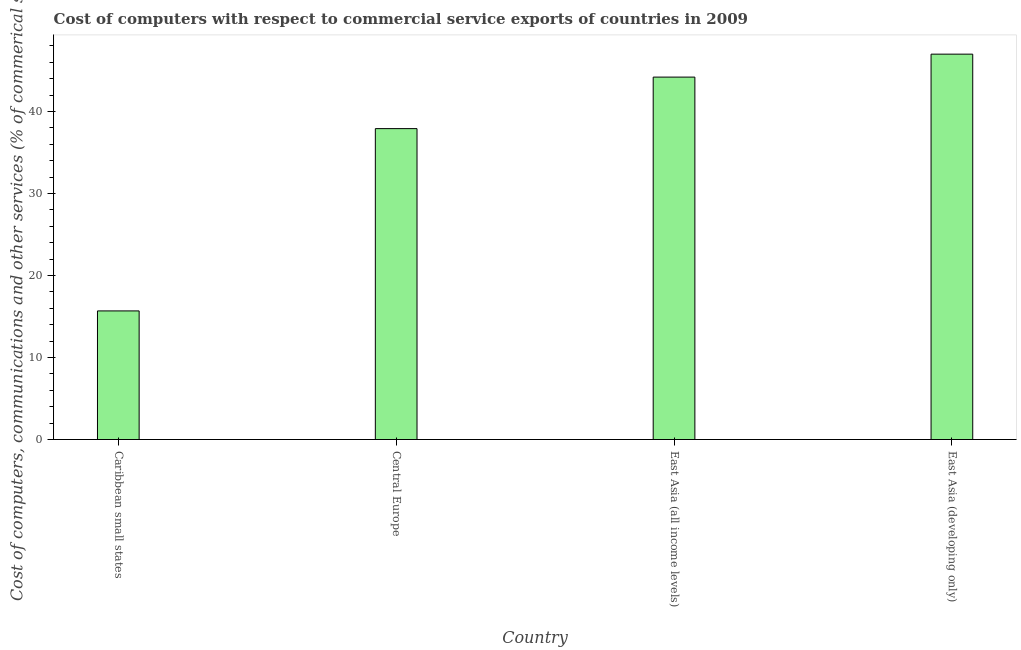Does the graph contain any zero values?
Make the answer very short. No. What is the title of the graph?
Your response must be concise. Cost of computers with respect to commercial service exports of countries in 2009. What is the label or title of the Y-axis?
Give a very brief answer. Cost of computers, communications and other services (% of commerical service exports). What is the cost of communications in Central Europe?
Make the answer very short. 37.91. Across all countries, what is the maximum  computer and other services?
Provide a succinct answer. 47. Across all countries, what is the minimum  computer and other services?
Your response must be concise. 15.68. In which country was the  computer and other services maximum?
Offer a terse response. East Asia (developing only). In which country was the  computer and other services minimum?
Offer a very short reply. Caribbean small states. What is the sum of the cost of communications?
Keep it short and to the point. 144.79. What is the difference between the  computer and other services in Central Europe and East Asia (all income levels)?
Your answer should be very brief. -6.28. What is the average  computer and other services per country?
Provide a short and direct response. 36.2. What is the median  computer and other services?
Your answer should be very brief. 41.06. What is the ratio of the  computer and other services in Central Europe to that in East Asia (all income levels)?
Give a very brief answer. 0.86. What is the difference between the highest and the second highest cost of communications?
Provide a succinct answer. 2.8. What is the difference between the highest and the lowest  computer and other services?
Give a very brief answer. 31.31. How many bars are there?
Ensure brevity in your answer.  4. Are all the bars in the graph horizontal?
Give a very brief answer. No. What is the Cost of computers, communications and other services (% of commerical service exports) of Caribbean small states?
Your response must be concise. 15.68. What is the Cost of computers, communications and other services (% of commerical service exports) of Central Europe?
Ensure brevity in your answer.  37.91. What is the Cost of computers, communications and other services (% of commerical service exports) in East Asia (all income levels)?
Keep it short and to the point. 44.2. What is the Cost of computers, communications and other services (% of commerical service exports) of East Asia (developing only)?
Your response must be concise. 47. What is the difference between the Cost of computers, communications and other services (% of commerical service exports) in Caribbean small states and Central Europe?
Offer a terse response. -22.23. What is the difference between the Cost of computers, communications and other services (% of commerical service exports) in Caribbean small states and East Asia (all income levels)?
Your answer should be compact. -28.51. What is the difference between the Cost of computers, communications and other services (% of commerical service exports) in Caribbean small states and East Asia (developing only)?
Offer a terse response. -31.31. What is the difference between the Cost of computers, communications and other services (% of commerical service exports) in Central Europe and East Asia (all income levels)?
Your answer should be compact. -6.28. What is the difference between the Cost of computers, communications and other services (% of commerical service exports) in Central Europe and East Asia (developing only)?
Ensure brevity in your answer.  -9.08. What is the difference between the Cost of computers, communications and other services (% of commerical service exports) in East Asia (all income levels) and East Asia (developing only)?
Ensure brevity in your answer.  -2.8. What is the ratio of the Cost of computers, communications and other services (% of commerical service exports) in Caribbean small states to that in Central Europe?
Offer a very short reply. 0.41. What is the ratio of the Cost of computers, communications and other services (% of commerical service exports) in Caribbean small states to that in East Asia (all income levels)?
Your answer should be very brief. 0.35. What is the ratio of the Cost of computers, communications and other services (% of commerical service exports) in Caribbean small states to that in East Asia (developing only)?
Provide a succinct answer. 0.33. What is the ratio of the Cost of computers, communications and other services (% of commerical service exports) in Central Europe to that in East Asia (all income levels)?
Provide a short and direct response. 0.86. What is the ratio of the Cost of computers, communications and other services (% of commerical service exports) in Central Europe to that in East Asia (developing only)?
Keep it short and to the point. 0.81. 